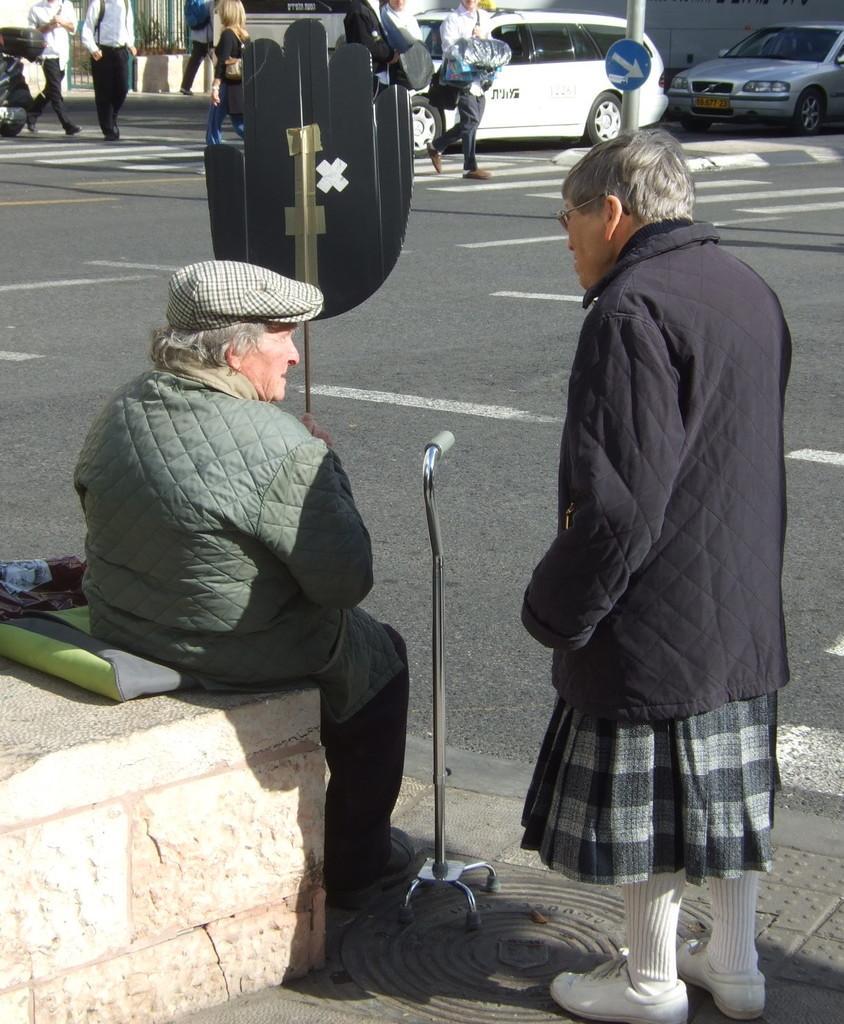Could you give a brief overview of what you see in this image? In this picture there are two old women in the center of the image and there is a walking stand in the center of the image, there are people, cars, and a pole at the top side of the image, there is a hand board in the image. 